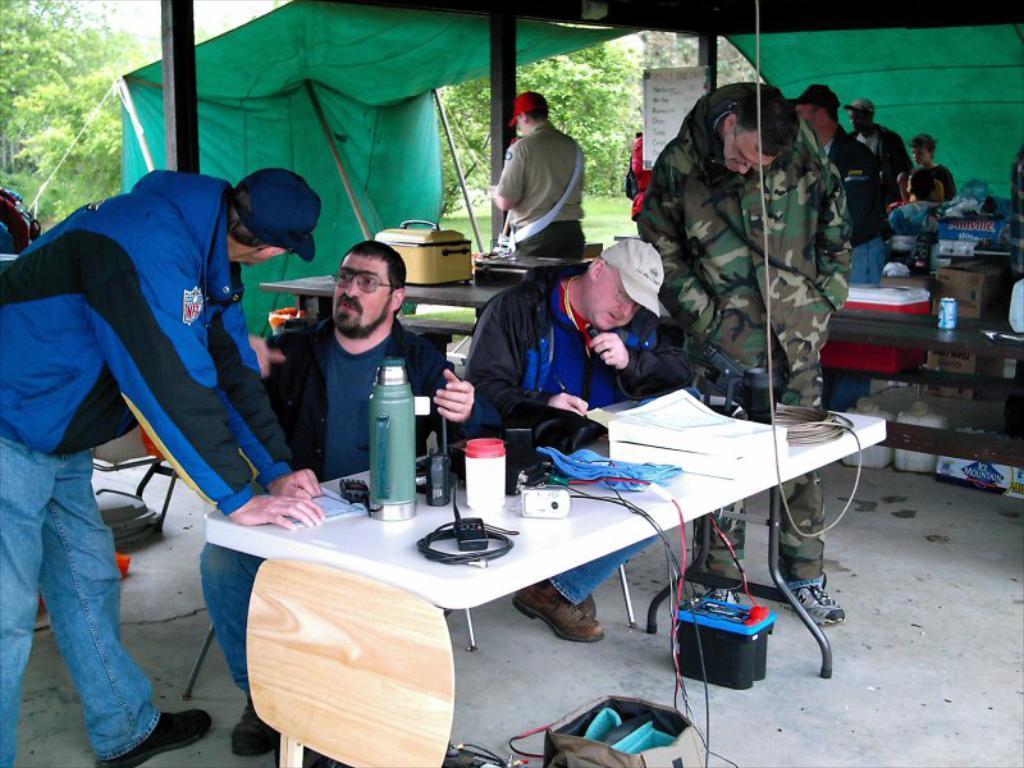In one or two sentences, can you explain what this image depicts? There are so many people standing under tent with table and water bottle. 